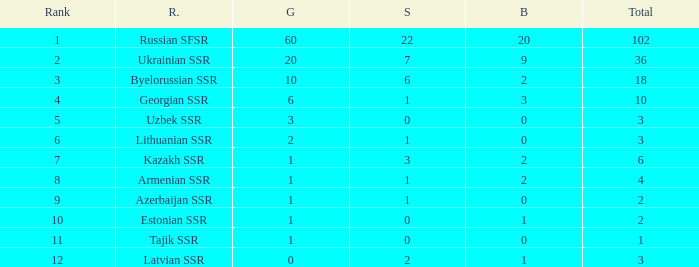What is the sum of silvers for teams with ranks over 3 and totals under 2? 0.0. 